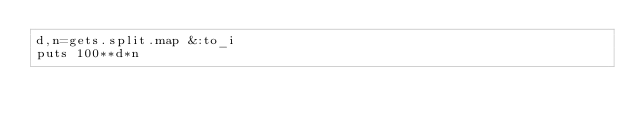Convert code to text. <code><loc_0><loc_0><loc_500><loc_500><_Ruby_>d,n=gets.split.map &:to_i
puts 100**d*n
</code> 